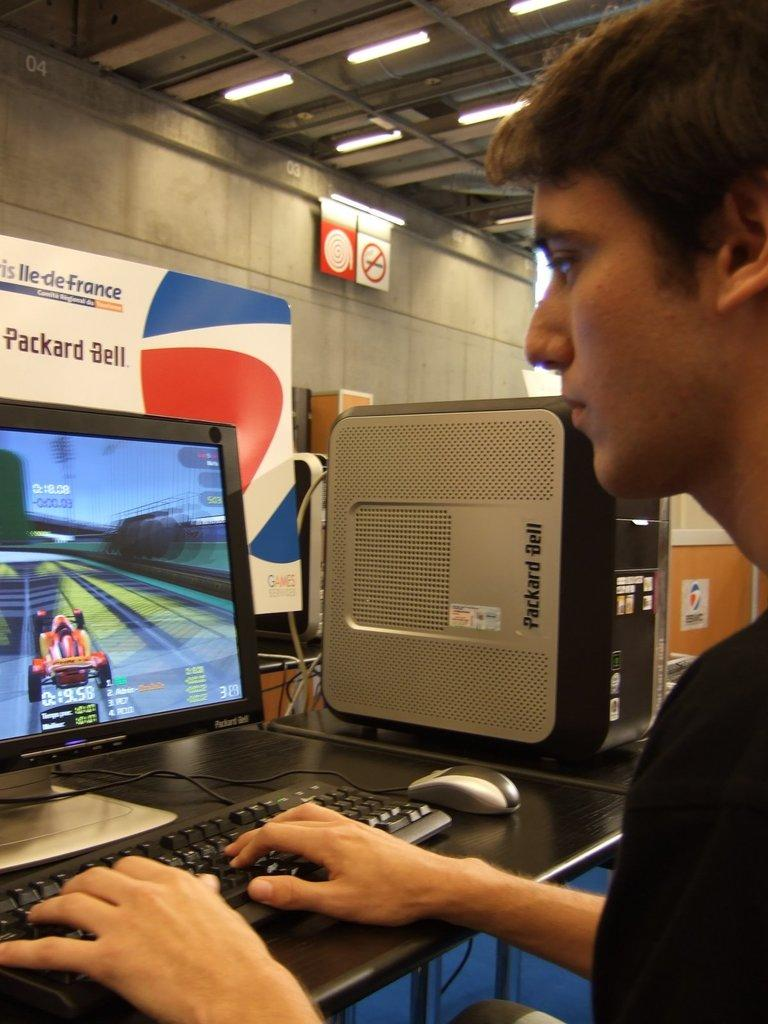Provide a one-sentence caption for the provided image. A teen male sitting in front of a computer, playing a racing game on a Packard Bell computer. 